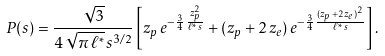Convert formula to latex. <formula><loc_0><loc_0><loc_500><loc_500>P ( s ) = \frac { \sqrt { 3 } } { 4 \, \sqrt { \pi \, \ell ^ { \ast } } \, s ^ { 3 / 2 } } \left [ z _ { p } \, e ^ { - \frac { 3 } { 4 } \, \frac { z ^ { 2 } _ { p } } { \ell ^ { \ast } \, s } } + ( z _ { p } + 2 \, z _ { e } ) \, e ^ { - \frac { 3 } { 4 } \, \frac { ( z _ { p } + 2 \, z _ { e } ) ^ { 2 } } { \ell ^ { \ast } \, s } } \right ] .</formula> 